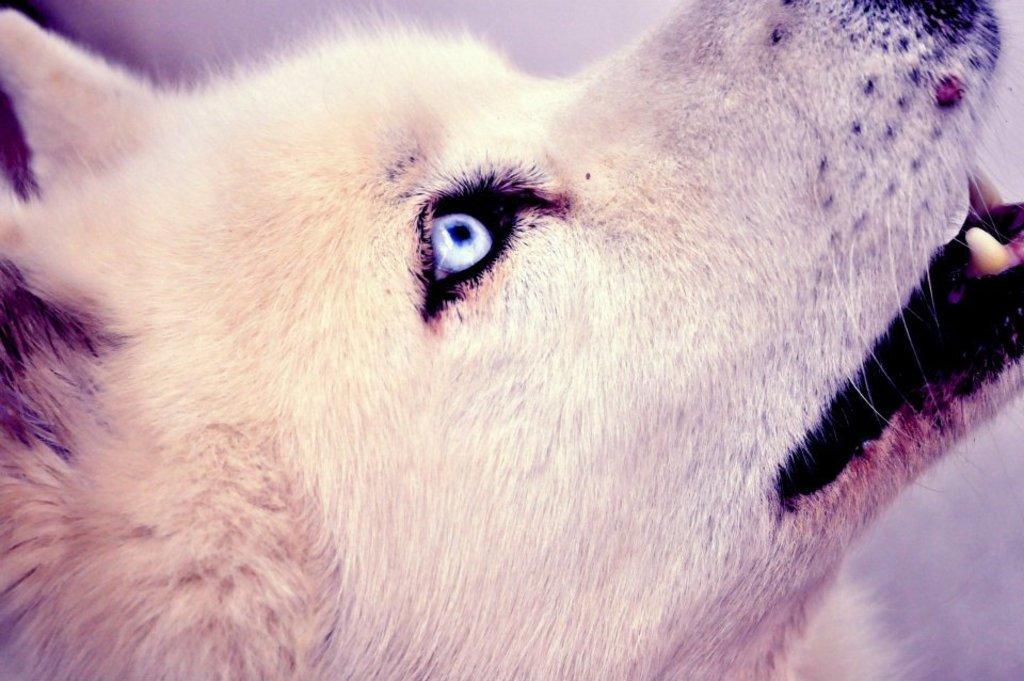Please provide a concise description of this image. In the picture we can see a dog's face from the side view which is looking up and it is with a cream color hair. 